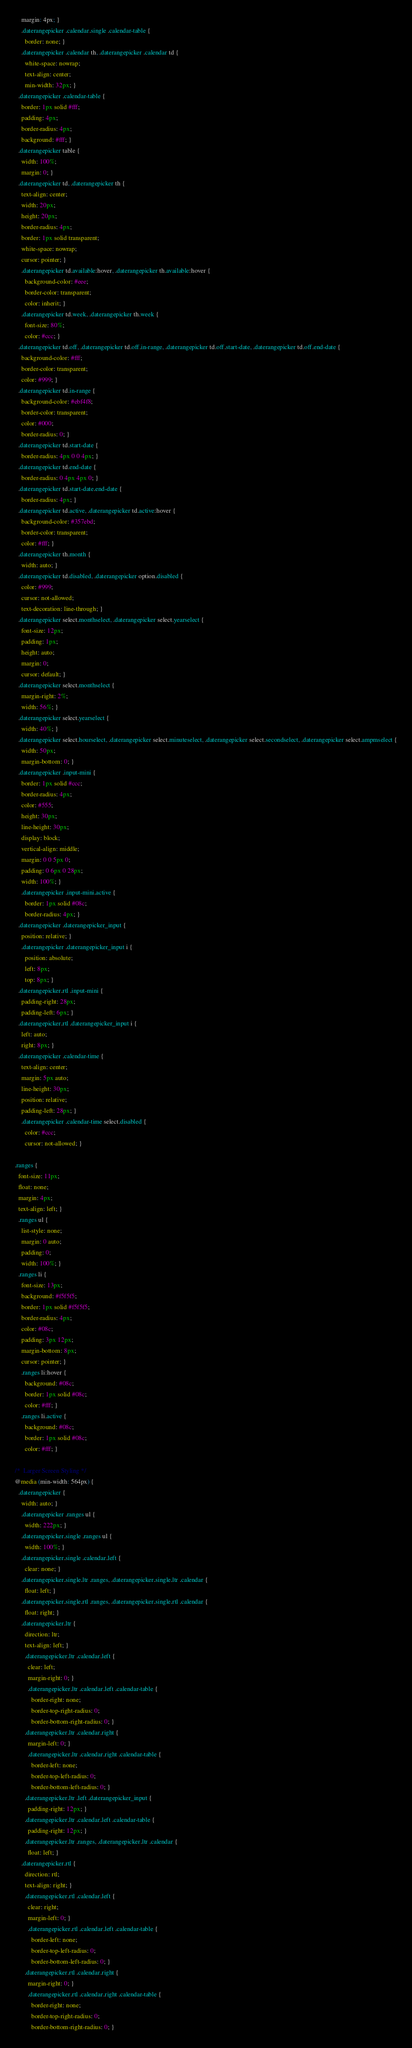<code> <loc_0><loc_0><loc_500><loc_500><_CSS_>    margin: 4px; }
    .daterangepicker .calendar.single .calendar-table {
      border: none; }
    .daterangepicker .calendar th, .daterangepicker .calendar td {
      white-space: nowrap;
      text-align: center;
      min-width: 32px; }
  .daterangepicker .calendar-table {
    border: 1px solid #fff;
    padding: 4px;
    border-radius: 4px;
    background: #fff; }
  .daterangepicker table {
    width: 100%;
    margin: 0; }
  .daterangepicker td, .daterangepicker th {
    text-align: center;
    width: 20px;
    height: 20px;
    border-radius: 4px;
    border: 1px solid transparent;
    white-space: nowrap;
    cursor: pointer; }
    .daterangepicker td.available:hover, .daterangepicker th.available:hover {
      background-color: #eee;
      border-color: transparent;
      color: inherit; }
    .daterangepicker td.week, .daterangepicker th.week {
      font-size: 80%;
      color: #ccc; }
  .daterangepicker td.off, .daterangepicker td.off.in-range, .daterangepicker td.off.start-date, .daterangepicker td.off.end-date {
    background-color: #fff;
    border-color: transparent;
    color: #999; }
  .daterangepicker td.in-range {
    background-color: #ebf4f8;
    border-color: transparent;
    color: #000;
    border-radius: 0; }
  .daterangepicker td.start-date {
    border-radius: 4px 0 0 4px; }
  .daterangepicker td.end-date {
    border-radius: 0 4px 4px 0; }
  .daterangepicker td.start-date.end-date {
    border-radius: 4px; }
  .daterangepicker td.active, .daterangepicker td.active:hover {
    background-color: #357ebd;
    border-color: transparent;
    color: #fff; }
  .daterangepicker th.month {
    width: auto; }
  .daterangepicker td.disabled, .daterangepicker option.disabled {
    color: #999;
    cursor: not-allowed;
    text-decoration: line-through; }
  .daterangepicker select.monthselect, .daterangepicker select.yearselect {
    font-size: 12px;
    padding: 1px;
    height: auto;
    margin: 0;
    cursor: default; }
  .daterangepicker select.monthselect {
    margin-right: 2%;
    width: 56%; }
  .daterangepicker select.yearselect {
    width: 40%; }
  .daterangepicker select.hourselect, .daterangepicker select.minuteselect, .daterangepicker select.secondselect, .daterangepicker select.ampmselect {
    width: 50px;
    margin-bottom: 0; }
  .daterangepicker .input-mini {
    border: 1px solid #ccc;
    border-radius: 4px;
    color: #555;
    height: 30px;
    line-height: 30px;
    display: block;
    vertical-align: middle;
    margin: 0 0 5px 0;
    padding: 0 6px 0 28px;
    width: 100%; }
    .daterangepicker .input-mini.active {
      border: 1px solid #08c;
      border-radius: 4px; }
  .daterangepicker .daterangepicker_input {
    position: relative; }
    .daterangepicker .daterangepicker_input i {
      position: absolute;
      left: 8px;
      top: 8px; }
  .daterangepicker.rtl .input-mini {
    padding-right: 28px;
    padding-left: 6px; }
  .daterangepicker.rtl .daterangepicker_input i {
    left: auto;
    right: 8px; }
  .daterangepicker .calendar-time {
    text-align: center;
    margin: 5px auto;
    line-height: 30px;
    position: relative;
    padding-left: 28px; }
    .daterangepicker .calendar-time select.disabled {
      color: #ccc;
      cursor: not-allowed; }

.ranges {
  font-size: 11px;
  float: none;
  margin: 4px;
  text-align: left; }
  .ranges ul {
    list-style: none;
    margin: 0 auto;
    padding: 0;
    width: 100%; }
  .ranges li {
    font-size: 13px;
    background: #f5f5f5;
    border: 1px solid #f5f5f5;
    border-radius: 4px;
    color: #08c;
    padding: 3px 12px;
    margin-bottom: 8px;
    cursor: pointer; }
    .ranges li:hover {
      background: #08c;
      border: 1px solid #08c;
      color: #fff; }
    .ranges li.active {
      background: #08c;
      border: 1px solid #08c;
      color: #fff; }

/*  Larger Screen Styling */
@media (min-width: 564px) {
  .daterangepicker {
    width: auto; }
    .daterangepicker .ranges ul {
      width: 222px; }
    .daterangepicker.single .ranges ul {
      width: 100%; }
    .daterangepicker.single .calendar.left {
      clear: none; }
    .daterangepicker.single.ltr .ranges, .daterangepicker.single.ltr .calendar {
      float: left; }
    .daterangepicker.single.rtl .ranges, .daterangepicker.single.rtl .calendar {
      float: right; }
    .daterangepicker.ltr {
      direction: ltr;
      text-align: left; }
      .daterangepicker.ltr .calendar.left {
        clear: left;
        margin-right: 0; }
        .daterangepicker.ltr .calendar.left .calendar-table {
          border-right: none;
          border-top-right-radius: 0;
          border-bottom-right-radius: 0; }
      .daterangepicker.ltr .calendar.right {
        margin-left: 0; }
        .daterangepicker.ltr .calendar.right .calendar-table {
          border-left: none;
          border-top-left-radius: 0;
          border-bottom-left-radius: 0; }
      .daterangepicker.ltr .left .daterangepicker_input {
        padding-right: 12px; }
      .daterangepicker.ltr .calendar.left .calendar-table {
        padding-right: 12px; }
      .daterangepicker.ltr .ranges, .daterangepicker.ltr .calendar {
        float: left; }
    .daterangepicker.rtl {
      direction: rtl;
      text-align: right; }
      .daterangepicker.rtl .calendar.left {
        clear: right;
        margin-left: 0; }
        .daterangepicker.rtl .calendar.left .calendar-table {
          border-left: none;
          border-top-left-radius: 0;
          border-bottom-left-radius: 0; }
      .daterangepicker.rtl .calendar.right {
        margin-right: 0; }
        .daterangepicker.rtl .calendar.right .calendar-table {
          border-right: none;
          border-top-right-radius: 0;
          border-bottom-right-radius: 0; }</code> 